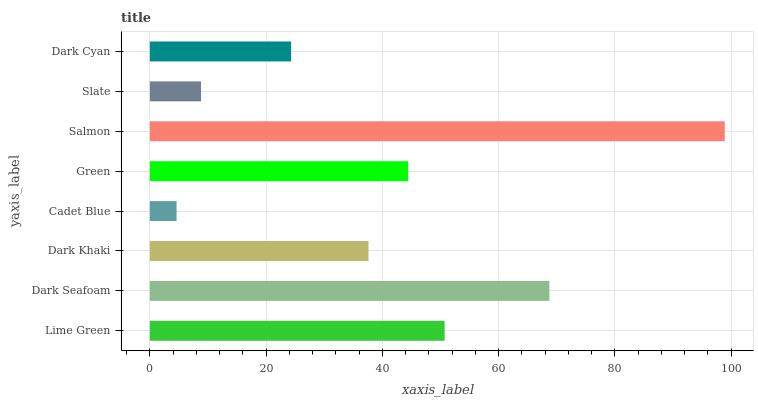Is Cadet Blue the minimum?
Answer yes or no. Yes. Is Salmon the maximum?
Answer yes or no. Yes. Is Dark Seafoam the minimum?
Answer yes or no. No. Is Dark Seafoam the maximum?
Answer yes or no. No. Is Dark Seafoam greater than Lime Green?
Answer yes or no. Yes. Is Lime Green less than Dark Seafoam?
Answer yes or no. Yes. Is Lime Green greater than Dark Seafoam?
Answer yes or no. No. Is Dark Seafoam less than Lime Green?
Answer yes or no. No. Is Green the high median?
Answer yes or no. Yes. Is Dark Khaki the low median?
Answer yes or no. Yes. Is Lime Green the high median?
Answer yes or no. No. Is Lime Green the low median?
Answer yes or no. No. 